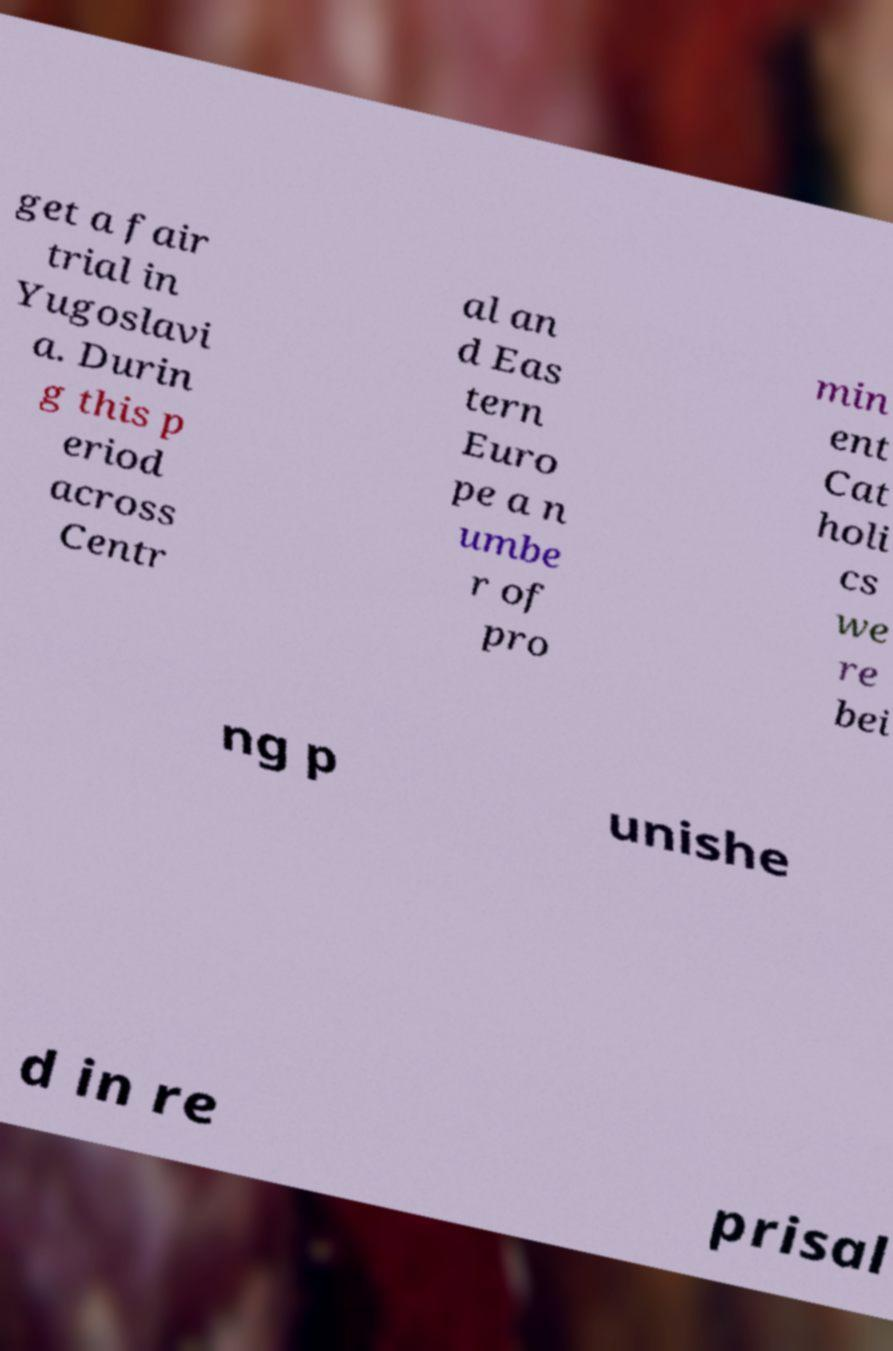Please identify and transcribe the text found in this image. get a fair trial in Yugoslavi a. Durin g this p eriod across Centr al an d Eas tern Euro pe a n umbe r of pro min ent Cat holi cs we re bei ng p unishe d in re prisal 